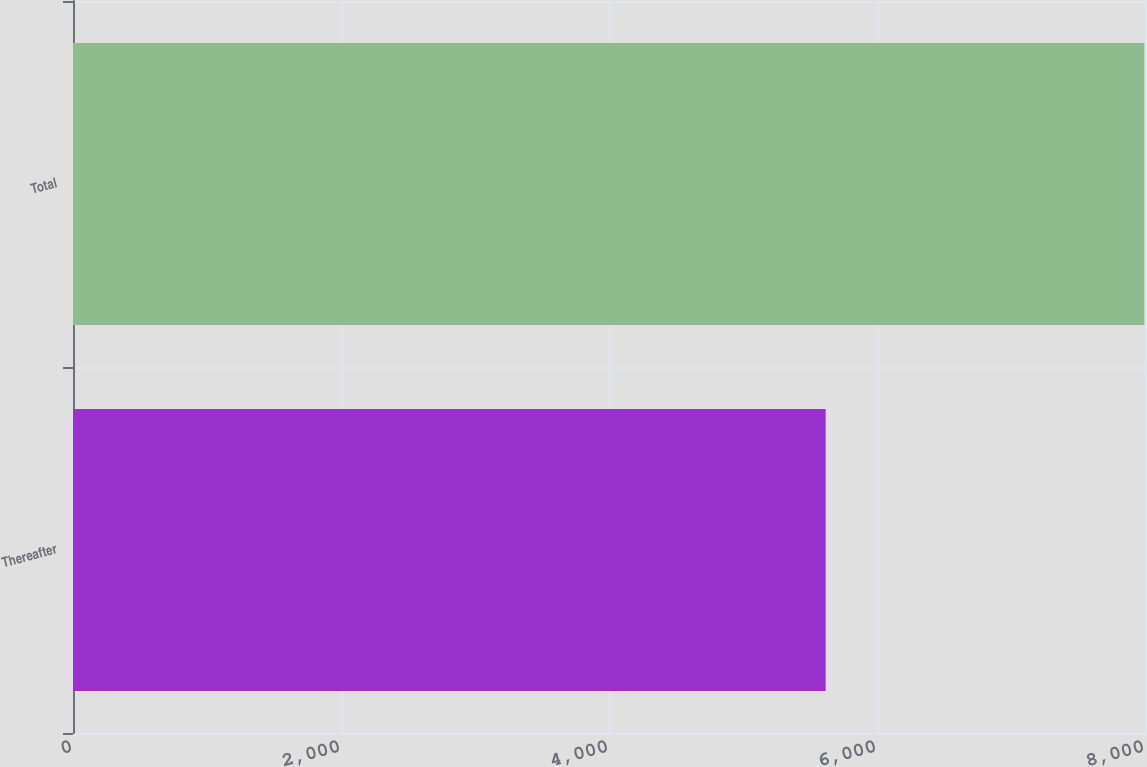Convert chart. <chart><loc_0><loc_0><loc_500><loc_500><bar_chart><fcel>Thereafter<fcel>Total<nl><fcel>5617<fcel>7995<nl></chart> 